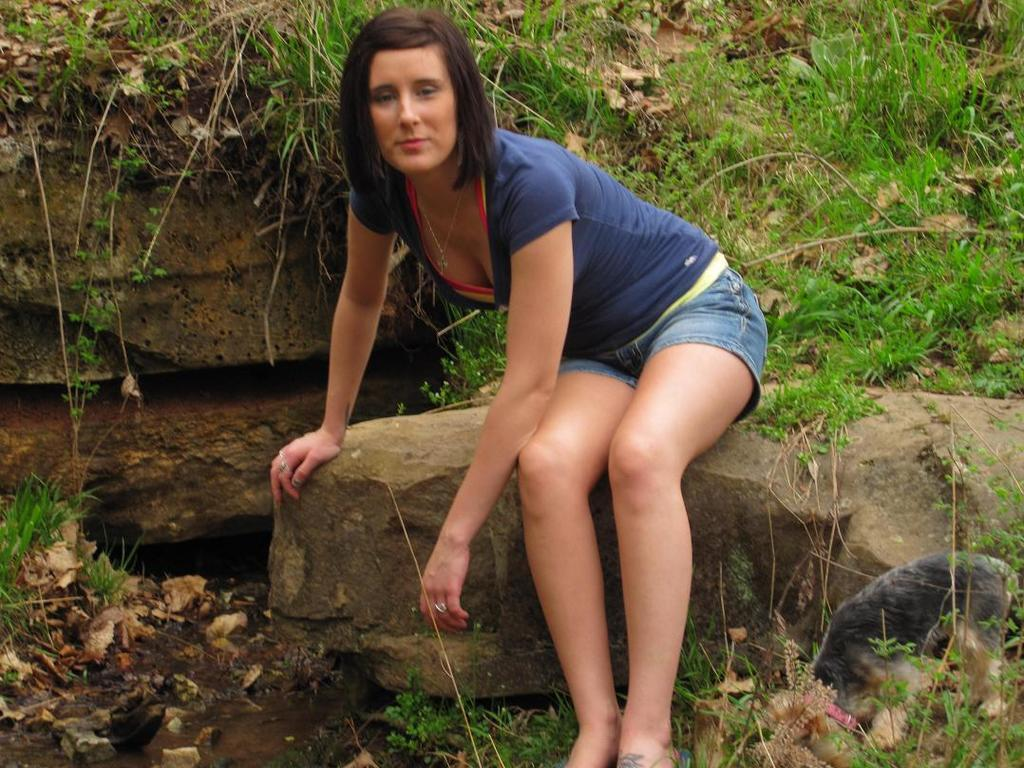Who is the main subject in the image? There is a lady in the image. What is the lady wearing? The lady is wearing shorts. What is the lady doing in the image? The lady is sitting on a rock. What can be seen in the background of the image? There are other rocks and plants in the background of the image. What type of meal is the lady eating in the image? There is no meal present in the image; the lady is sitting on a rock. 